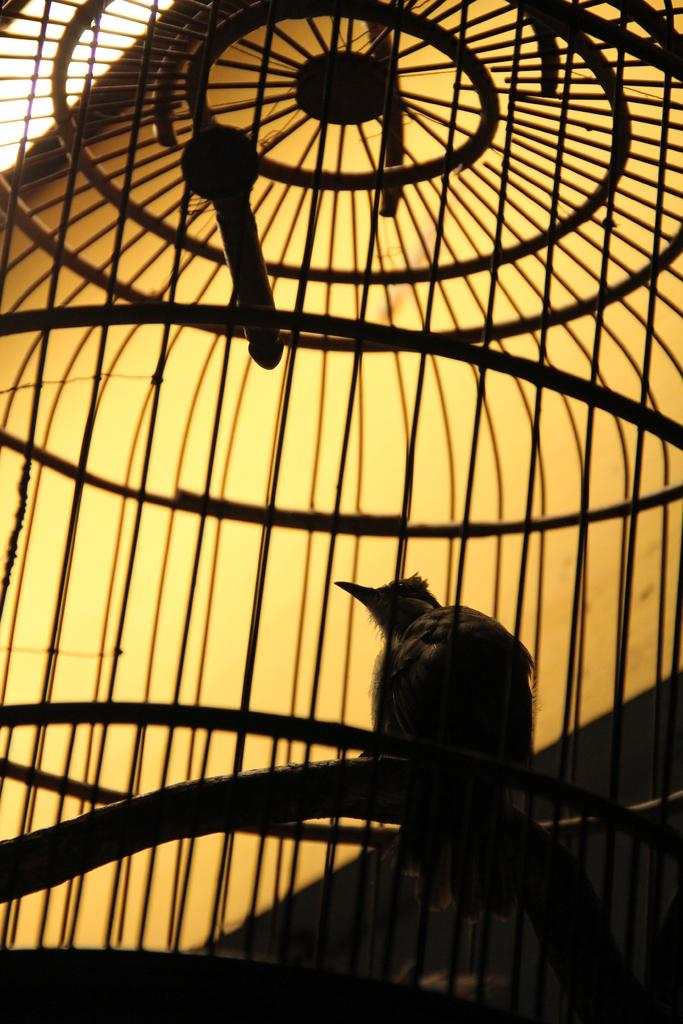What type of animal is in the image? There is a bird in the image. What is the bird standing on? The bird is standing on a cage. What can be seen in the background of the image? There is sky visible in the background of the image. How many clocks are hanging on the tent in the image? There is no tent or clocks present in the image; it features a bird standing on a cage with sky visible in the background. 